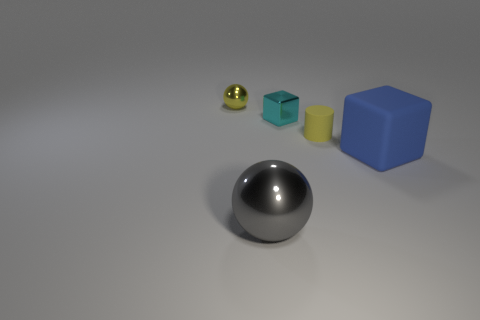Add 1 yellow metallic spheres. How many objects exist? 6 Subtract all spheres. How many objects are left? 3 Add 3 big matte objects. How many big matte objects are left? 4 Add 3 large red matte things. How many large red matte things exist? 3 Subtract 0 red balls. How many objects are left? 5 Subtract all large gray balls. Subtract all cyan metal objects. How many objects are left? 3 